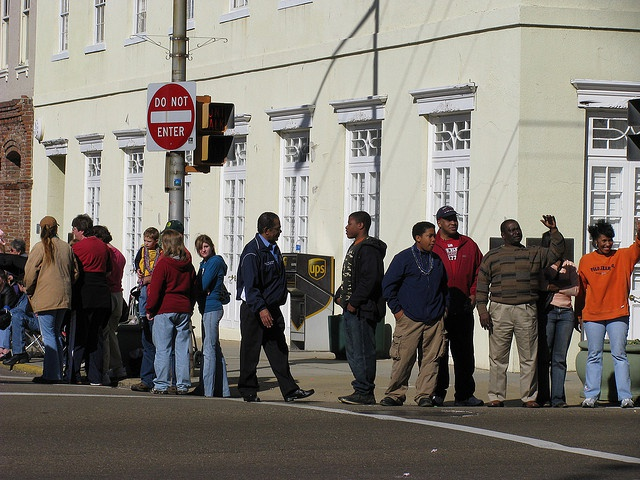Describe the objects in this image and their specific colors. I can see people in gray and black tones, people in gray and black tones, people in gray, black, and maroon tones, people in gray, black, lightgray, and maroon tones, and people in gray, brown, black, and red tones in this image. 